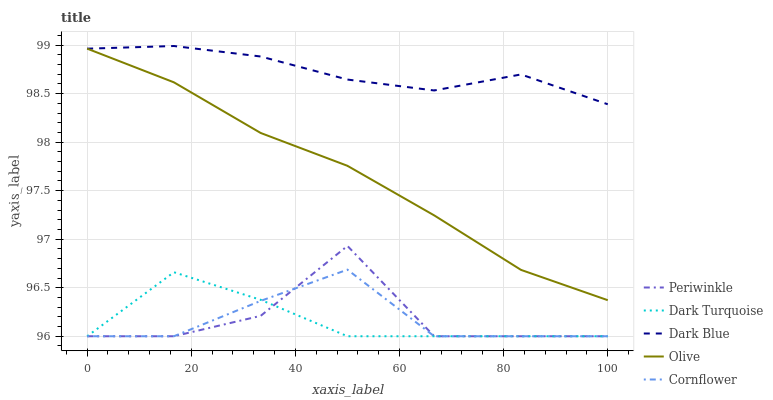Does Dark Turquoise have the minimum area under the curve?
Answer yes or no. Yes. Does Dark Blue have the maximum area under the curve?
Answer yes or no. Yes. Does Periwinkle have the minimum area under the curve?
Answer yes or no. No. Does Periwinkle have the maximum area under the curve?
Answer yes or no. No. Is Olive the smoothest?
Answer yes or no. Yes. Is Periwinkle the roughest?
Answer yes or no. Yes. Is Dark Turquoise the smoothest?
Answer yes or no. No. Is Dark Turquoise the roughest?
Answer yes or no. No. Does Dark Turquoise have the lowest value?
Answer yes or no. Yes. Does Dark Blue have the lowest value?
Answer yes or no. No. Does Dark Blue have the highest value?
Answer yes or no. Yes. Does Periwinkle have the highest value?
Answer yes or no. No. Is Periwinkle less than Dark Blue?
Answer yes or no. Yes. Is Dark Blue greater than Periwinkle?
Answer yes or no. Yes. Does Periwinkle intersect Dark Turquoise?
Answer yes or no. Yes. Is Periwinkle less than Dark Turquoise?
Answer yes or no. No. Is Periwinkle greater than Dark Turquoise?
Answer yes or no. No. Does Periwinkle intersect Dark Blue?
Answer yes or no. No. 